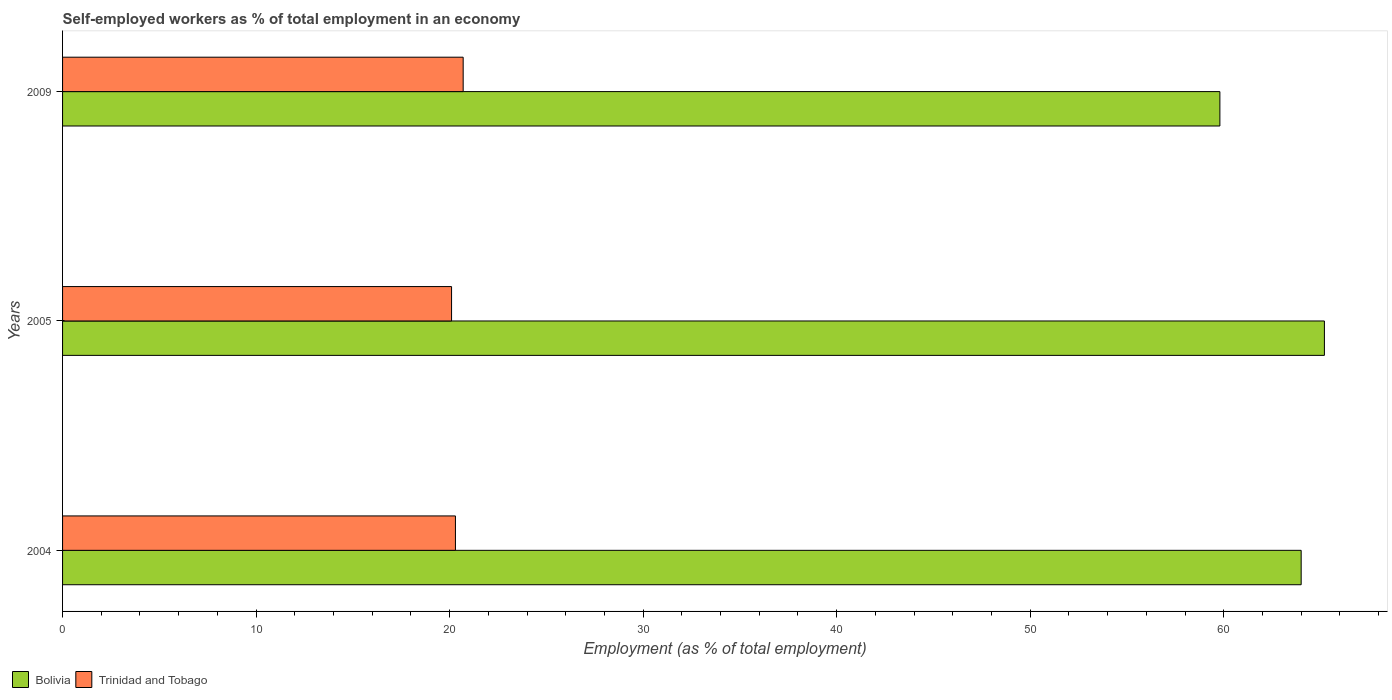How many groups of bars are there?
Offer a terse response. 3. Are the number of bars per tick equal to the number of legend labels?
Provide a succinct answer. Yes. How many bars are there on the 3rd tick from the top?
Ensure brevity in your answer.  2. In how many cases, is the number of bars for a given year not equal to the number of legend labels?
Keep it short and to the point. 0. What is the percentage of self-employed workers in Trinidad and Tobago in 2009?
Ensure brevity in your answer.  20.7. Across all years, what is the maximum percentage of self-employed workers in Trinidad and Tobago?
Your response must be concise. 20.7. Across all years, what is the minimum percentage of self-employed workers in Trinidad and Tobago?
Your response must be concise. 20.1. In which year was the percentage of self-employed workers in Trinidad and Tobago maximum?
Your answer should be compact. 2009. What is the total percentage of self-employed workers in Bolivia in the graph?
Your answer should be compact. 189. What is the difference between the percentage of self-employed workers in Trinidad and Tobago in 2004 and that in 2005?
Provide a short and direct response. 0.2. What is the difference between the percentage of self-employed workers in Trinidad and Tobago in 2004 and the percentage of self-employed workers in Bolivia in 2005?
Your answer should be very brief. -44.9. What is the average percentage of self-employed workers in Bolivia per year?
Provide a short and direct response. 63. In the year 2009, what is the difference between the percentage of self-employed workers in Trinidad and Tobago and percentage of self-employed workers in Bolivia?
Your answer should be very brief. -39.1. What is the ratio of the percentage of self-employed workers in Bolivia in 2005 to that in 2009?
Your answer should be very brief. 1.09. Is the percentage of self-employed workers in Bolivia in 2004 less than that in 2005?
Your answer should be very brief. Yes. What is the difference between the highest and the second highest percentage of self-employed workers in Trinidad and Tobago?
Your response must be concise. 0.4. What is the difference between the highest and the lowest percentage of self-employed workers in Trinidad and Tobago?
Provide a short and direct response. 0.6. In how many years, is the percentage of self-employed workers in Trinidad and Tobago greater than the average percentage of self-employed workers in Trinidad and Tobago taken over all years?
Make the answer very short. 1. What does the 2nd bar from the top in 2004 represents?
Your response must be concise. Bolivia. What does the 2nd bar from the bottom in 2009 represents?
Your response must be concise. Trinidad and Tobago. How many years are there in the graph?
Provide a short and direct response. 3. Are the values on the major ticks of X-axis written in scientific E-notation?
Offer a terse response. No. Does the graph contain any zero values?
Offer a very short reply. No. Does the graph contain grids?
Offer a terse response. No. How many legend labels are there?
Offer a terse response. 2. How are the legend labels stacked?
Your answer should be compact. Horizontal. What is the title of the graph?
Make the answer very short. Self-employed workers as % of total employment in an economy. Does "Uganda" appear as one of the legend labels in the graph?
Ensure brevity in your answer.  No. What is the label or title of the X-axis?
Your answer should be compact. Employment (as % of total employment). What is the Employment (as % of total employment) of Bolivia in 2004?
Offer a very short reply. 64. What is the Employment (as % of total employment) of Trinidad and Tobago in 2004?
Offer a very short reply. 20.3. What is the Employment (as % of total employment) of Bolivia in 2005?
Your answer should be compact. 65.2. What is the Employment (as % of total employment) in Trinidad and Tobago in 2005?
Your response must be concise. 20.1. What is the Employment (as % of total employment) of Bolivia in 2009?
Keep it short and to the point. 59.8. What is the Employment (as % of total employment) in Trinidad and Tobago in 2009?
Provide a succinct answer. 20.7. Across all years, what is the maximum Employment (as % of total employment) in Bolivia?
Offer a very short reply. 65.2. Across all years, what is the maximum Employment (as % of total employment) of Trinidad and Tobago?
Your response must be concise. 20.7. Across all years, what is the minimum Employment (as % of total employment) in Bolivia?
Keep it short and to the point. 59.8. Across all years, what is the minimum Employment (as % of total employment) in Trinidad and Tobago?
Keep it short and to the point. 20.1. What is the total Employment (as % of total employment) of Bolivia in the graph?
Offer a terse response. 189. What is the total Employment (as % of total employment) in Trinidad and Tobago in the graph?
Give a very brief answer. 61.1. What is the difference between the Employment (as % of total employment) of Bolivia in 2004 and that in 2005?
Offer a very short reply. -1.2. What is the difference between the Employment (as % of total employment) in Bolivia in 2004 and that in 2009?
Provide a short and direct response. 4.2. What is the difference between the Employment (as % of total employment) in Trinidad and Tobago in 2004 and that in 2009?
Ensure brevity in your answer.  -0.4. What is the difference between the Employment (as % of total employment) in Bolivia in 2005 and that in 2009?
Provide a short and direct response. 5.4. What is the difference between the Employment (as % of total employment) of Bolivia in 2004 and the Employment (as % of total employment) of Trinidad and Tobago in 2005?
Your response must be concise. 43.9. What is the difference between the Employment (as % of total employment) of Bolivia in 2004 and the Employment (as % of total employment) of Trinidad and Tobago in 2009?
Make the answer very short. 43.3. What is the difference between the Employment (as % of total employment) of Bolivia in 2005 and the Employment (as % of total employment) of Trinidad and Tobago in 2009?
Provide a short and direct response. 44.5. What is the average Employment (as % of total employment) in Trinidad and Tobago per year?
Your response must be concise. 20.37. In the year 2004, what is the difference between the Employment (as % of total employment) in Bolivia and Employment (as % of total employment) in Trinidad and Tobago?
Provide a short and direct response. 43.7. In the year 2005, what is the difference between the Employment (as % of total employment) in Bolivia and Employment (as % of total employment) in Trinidad and Tobago?
Ensure brevity in your answer.  45.1. In the year 2009, what is the difference between the Employment (as % of total employment) in Bolivia and Employment (as % of total employment) in Trinidad and Tobago?
Keep it short and to the point. 39.1. What is the ratio of the Employment (as % of total employment) of Bolivia in 2004 to that in 2005?
Give a very brief answer. 0.98. What is the ratio of the Employment (as % of total employment) of Bolivia in 2004 to that in 2009?
Offer a terse response. 1.07. What is the ratio of the Employment (as % of total employment) of Trinidad and Tobago in 2004 to that in 2009?
Your answer should be very brief. 0.98. What is the ratio of the Employment (as % of total employment) of Bolivia in 2005 to that in 2009?
Give a very brief answer. 1.09. What is the difference between the highest and the second highest Employment (as % of total employment) in Bolivia?
Provide a succinct answer. 1.2. What is the difference between the highest and the second highest Employment (as % of total employment) in Trinidad and Tobago?
Offer a terse response. 0.4. 